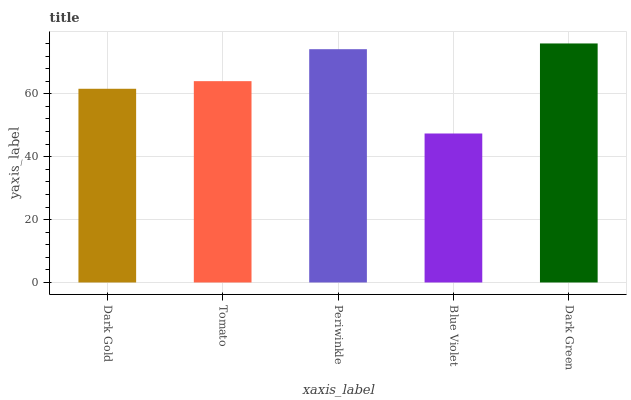Is Blue Violet the minimum?
Answer yes or no. Yes. Is Dark Green the maximum?
Answer yes or no. Yes. Is Tomato the minimum?
Answer yes or no. No. Is Tomato the maximum?
Answer yes or no. No. Is Tomato greater than Dark Gold?
Answer yes or no. Yes. Is Dark Gold less than Tomato?
Answer yes or no. Yes. Is Dark Gold greater than Tomato?
Answer yes or no. No. Is Tomato less than Dark Gold?
Answer yes or no. No. Is Tomato the high median?
Answer yes or no. Yes. Is Tomato the low median?
Answer yes or no. Yes. Is Periwinkle the high median?
Answer yes or no. No. Is Periwinkle the low median?
Answer yes or no. No. 